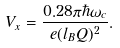<formula> <loc_0><loc_0><loc_500><loc_500>V _ { x } = \frac { 0 . 2 8 \pi \hbar { \omega } _ { c } } { e ( l _ { B } Q ) ^ { 2 } } .</formula> 